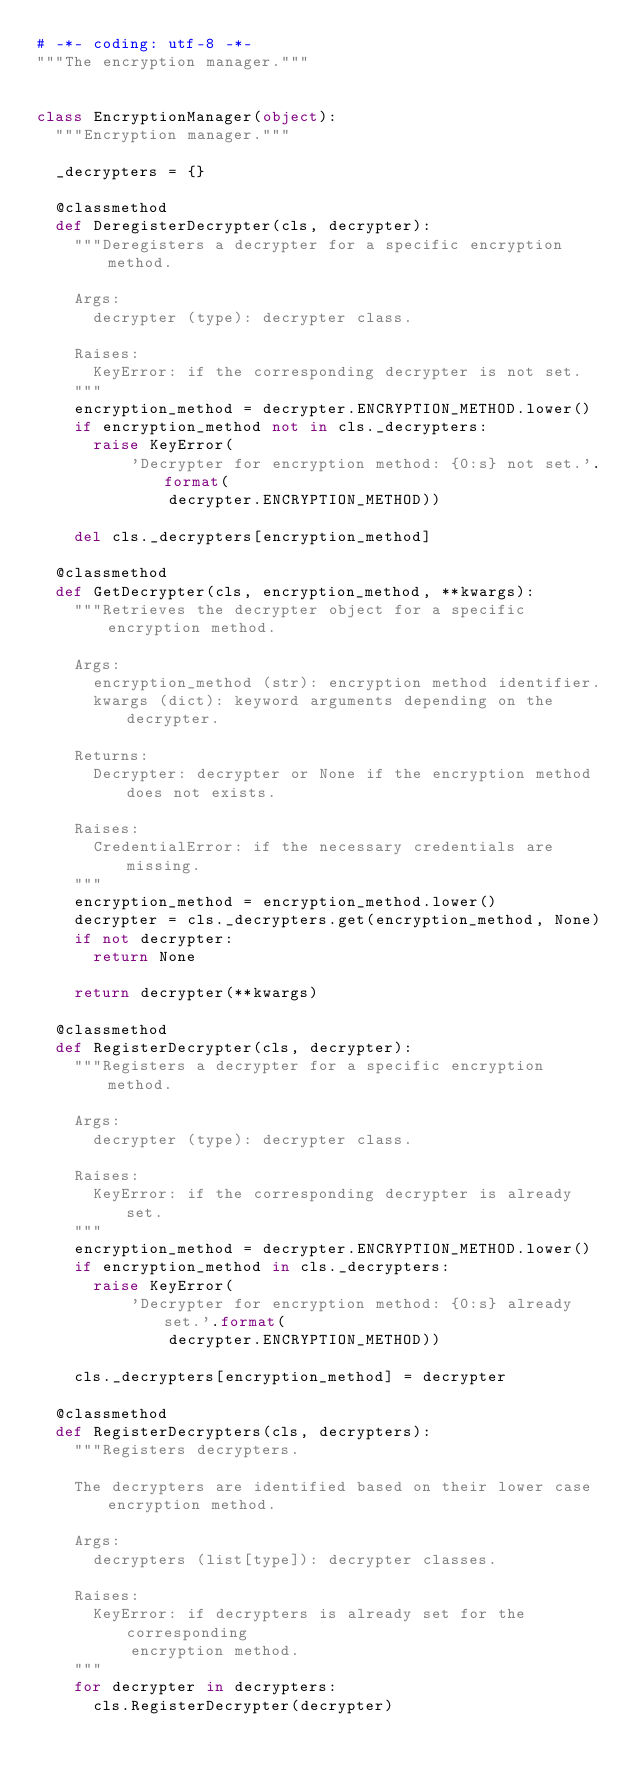Convert code to text. <code><loc_0><loc_0><loc_500><loc_500><_Python_># -*- coding: utf-8 -*-
"""The encryption manager."""


class EncryptionManager(object):
  """Encryption manager."""

  _decrypters = {}

  @classmethod
  def DeregisterDecrypter(cls, decrypter):
    """Deregisters a decrypter for a specific encryption method.

    Args:
      decrypter (type): decrypter class.

    Raises:
      KeyError: if the corresponding decrypter is not set.
    """
    encryption_method = decrypter.ENCRYPTION_METHOD.lower()
    if encryption_method not in cls._decrypters:
      raise KeyError(
          'Decrypter for encryption method: {0:s} not set.'.format(
              decrypter.ENCRYPTION_METHOD))

    del cls._decrypters[encryption_method]

  @classmethod
  def GetDecrypter(cls, encryption_method, **kwargs):
    """Retrieves the decrypter object for a specific encryption method.

    Args:
      encryption_method (str): encryption method identifier.
      kwargs (dict): keyword arguments depending on the decrypter.

    Returns:
      Decrypter: decrypter or None if the encryption method does not exists.

    Raises:
      CredentialError: if the necessary credentials are missing.
    """
    encryption_method = encryption_method.lower()
    decrypter = cls._decrypters.get(encryption_method, None)
    if not decrypter:
      return None

    return decrypter(**kwargs)

  @classmethod
  def RegisterDecrypter(cls, decrypter):
    """Registers a decrypter for a specific encryption method.

    Args:
      decrypter (type): decrypter class.

    Raises:
      KeyError: if the corresponding decrypter is already set.
    """
    encryption_method = decrypter.ENCRYPTION_METHOD.lower()
    if encryption_method in cls._decrypters:
      raise KeyError(
          'Decrypter for encryption method: {0:s} already set.'.format(
              decrypter.ENCRYPTION_METHOD))

    cls._decrypters[encryption_method] = decrypter

  @classmethod
  def RegisterDecrypters(cls, decrypters):
    """Registers decrypters.

    The decrypters are identified based on their lower case encryption method.

    Args:
      decrypters (list[type]): decrypter classes.

    Raises:
      KeyError: if decrypters is already set for the corresponding
          encryption method.
    """
    for decrypter in decrypters:
      cls.RegisterDecrypter(decrypter)
</code> 